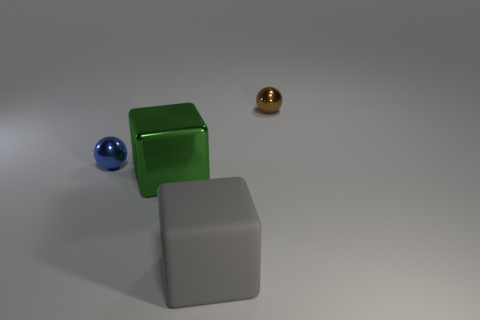Subtract all gray blocks. How many blocks are left? 1 Add 4 gray things. How many objects exist? 8 Add 2 large gray rubber objects. How many large gray rubber objects are left? 3 Add 1 tiny blue balls. How many tiny blue balls exist? 2 Subtract 0 cyan cylinders. How many objects are left? 4 Subtract 2 cubes. How many cubes are left? 0 Subtract all blue cubes. Subtract all yellow spheres. How many cubes are left? 2 Subtract all cyan cubes. How many blue balls are left? 1 Subtract all big green metallic things. Subtract all gray rubber blocks. How many objects are left? 2 